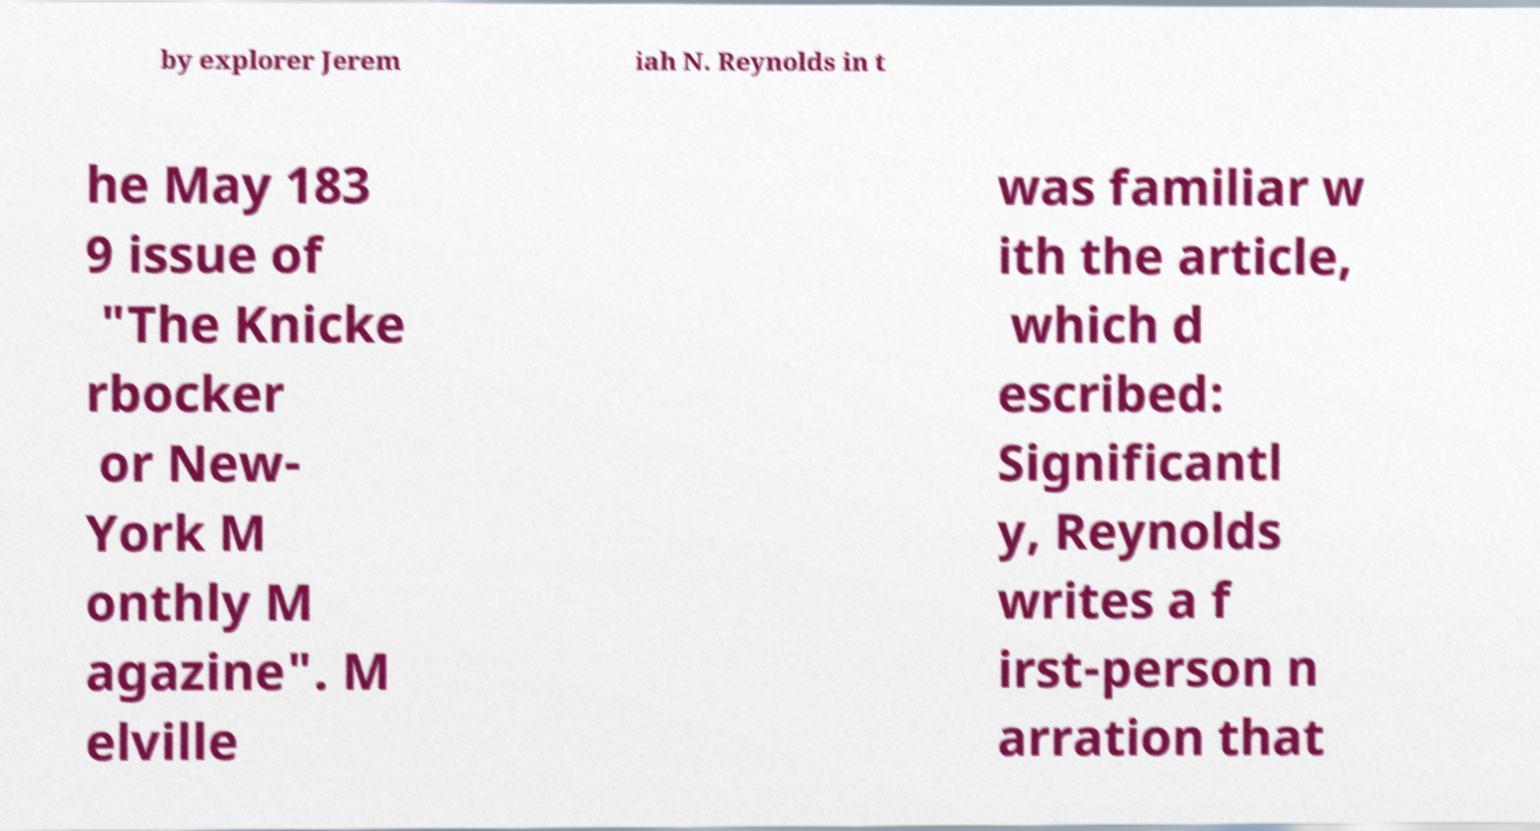There's text embedded in this image that I need extracted. Can you transcribe it verbatim? by explorer Jerem iah N. Reynolds in t he May 183 9 issue of "The Knicke rbocker or New- York M onthly M agazine". M elville was familiar w ith the article, which d escribed: Significantl y, Reynolds writes a f irst-person n arration that 